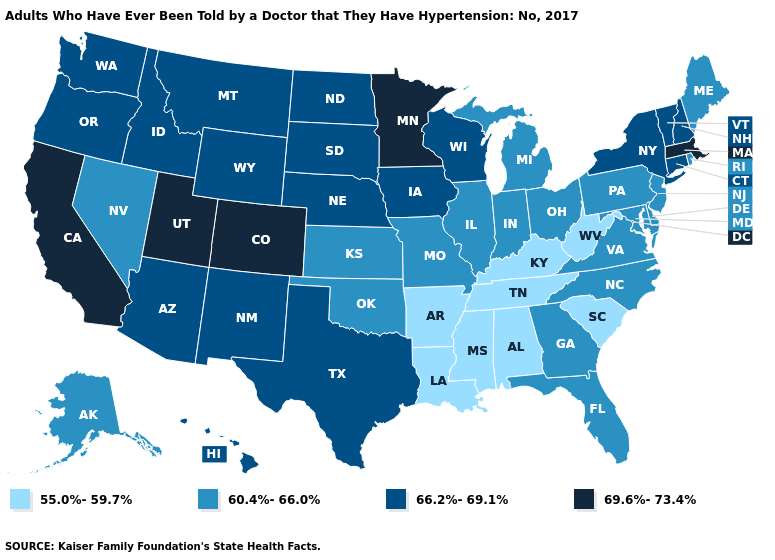Does Minnesota have the highest value in the MidWest?
Answer briefly. Yes. Name the states that have a value in the range 66.2%-69.1%?
Short answer required. Arizona, Connecticut, Hawaii, Idaho, Iowa, Montana, Nebraska, New Hampshire, New Mexico, New York, North Dakota, Oregon, South Dakota, Texas, Vermont, Washington, Wisconsin, Wyoming. Does Massachusetts have the highest value in the Northeast?
Keep it brief. Yes. What is the value of Pennsylvania?
Give a very brief answer. 60.4%-66.0%. What is the lowest value in the USA?
Short answer required. 55.0%-59.7%. Which states have the highest value in the USA?
Answer briefly. California, Colorado, Massachusetts, Minnesota, Utah. Among the states that border New Jersey , does Pennsylvania have the lowest value?
Concise answer only. Yes. Does Vermont have the lowest value in the Northeast?
Keep it brief. No. Name the states that have a value in the range 66.2%-69.1%?
Give a very brief answer. Arizona, Connecticut, Hawaii, Idaho, Iowa, Montana, Nebraska, New Hampshire, New Mexico, New York, North Dakota, Oregon, South Dakota, Texas, Vermont, Washington, Wisconsin, Wyoming. Name the states that have a value in the range 55.0%-59.7%?
Concise answer only. Alabama, Arkansas, Kentucky, Louisiana, Mississippi, South Carolina, Tennessee, West Virginia. Does Pennsylvania have the highest value in the USA?
Keep it brief. No. Name the states that have a value in the range 55.0%-59.7%?
Quick response, please. Alabama, Arkansas, Kentucky, Louisiana, Mississippi, South Carolina, Tennessee, West Virginia. Does New Mexico have a higher value than Nevada?
Short answer required. Yes. What is the lowest value in states that border Montana?
Quick response, please. 66.2%-69.1%. What is the value of Louisiana?
Quick response, please. 55.0%-59.7%. 